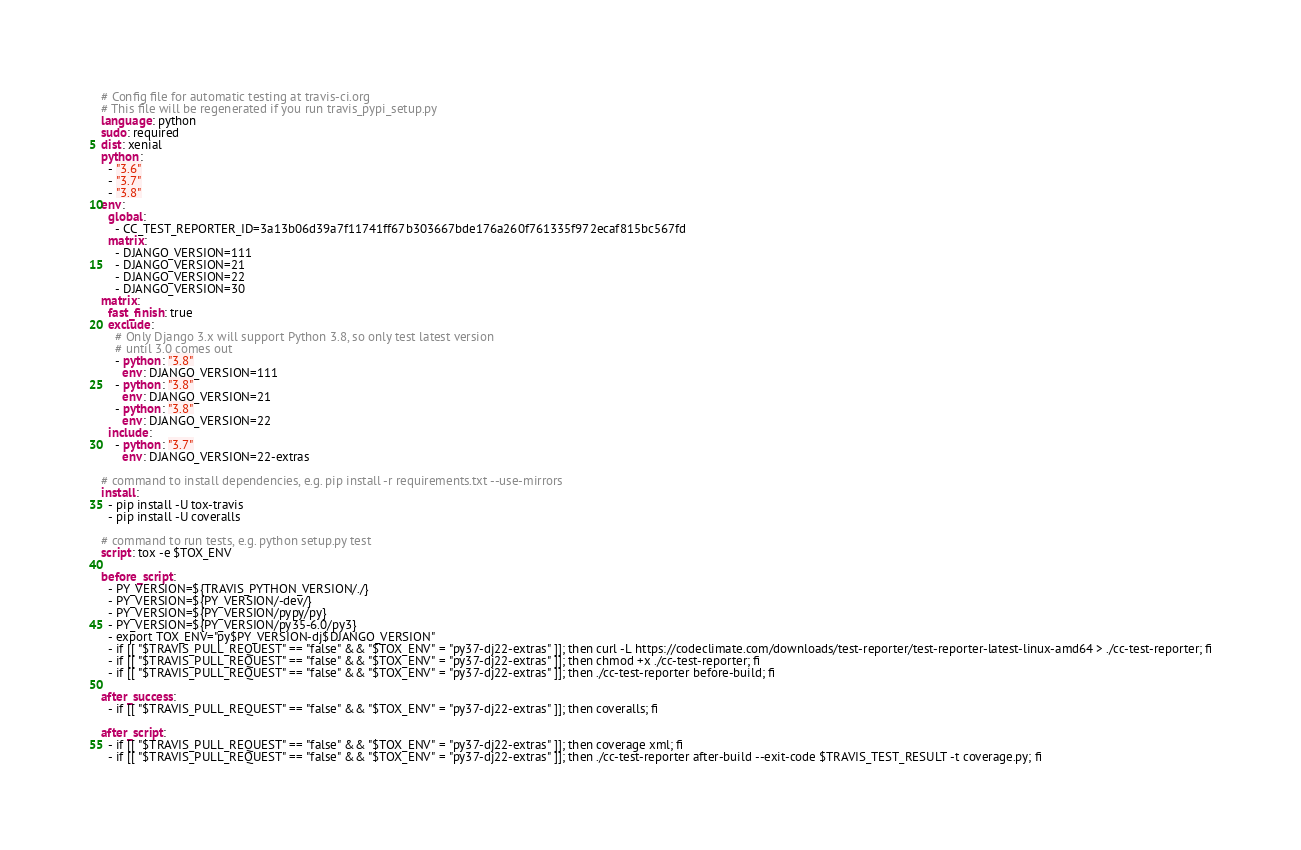<code> <loc_0><loc_0><loc_500><loc_500><_YAML_># Config file for automatic testing at travis-ci.org
# This file will be regenerated if you run travis_pypi_setup.py
language: python
sudo: required
dist: xenial
python:
  - "3.6"
  - "3.7"
  - "3.8"
env:
  global:
    - CC_TEST_REPORTER_ID=3a13b06d39a7f11741ff67b303667bde176a260f761335f972ecaf815bc567fd
  matrix:
    - DJANGO_VERSION=111
    - DJANGO_VERSION=21
    - DJANGO_VERSION=22
    - DJANGO_VERSION=30
matrix:
  fast_finish: true
  exclude:
    # Only Django 3.x will support Python 3.8, so only test latest version
    # until 3.0 comes out
    - python: "3.8"
      env: DJANGO_VERSION=111
    - python: "3.8"
      env: DJANGO_VERSION=21
    - python: "3.8"
      env: DJANGO_VERSION=22
  include:
    - python: "3.7"
      env: DJANGO_VERSION=22-extras

# command to install dependencies, e.g. pip install -r requirements.txt --use-mirrors
install:
  - pip install -U tox-travis
  - pip install -U coveralls

# command to run tests, e.g. python setup.py test
script: tox -e $TOX_ENV

before_script:
  - PY_VERSION=${TRAVIS_PYTHON_VERSION/./}
  - PY_VERSION=${PY_VERSION/-dev/}
  - PY_VERSION=${PY_VERSION/pypy/py}
  - PY_VERSION=${PY_VERSION/py35-6.0/py3}
  - export TOX_ENV="py$PY_VERSION-dj$DJANGO_VERSION"
  - if [[ "$TRAVIS_PULL_REQUEST" == "false" && "$TOX_ENV" = "py37-dj22-extras" ]]; then curl -L https://codeclimate.com/downloads/test-reporter/test-reporter-latest-linux-amd64 > ./cc-test-reporter; fi
  - if [[ "$TRAVIS_PULL_REQUEST" == "false" && "$TOX_ENV" = "py37-dj22-extras" ]]; then chmod +x ./cc-test-reporter; fi
  - if [[ "$TRAVIS_PULL_REQUEST" == "false" && "$TOX_ENV" = "py37-dj22-extras" ]]; then ./cc-test-reporter before-build; fi

after_success:
  - if [[ "$TRAVIS_PULL_REQUEST" == "false" && "$TOX_ENV" = "py37-dj22-extras" ]]; then coveralls; fi

after_script:
  - if [[ "$TRAVIS_PULL_REQUEST" == "false" && "$TOX_ENV" = "py37-dj22-extras" ]]; then coverage xml; fi
  - if [[ "$TRAVIS_PULL_REQUEST" == "false" && "$TOX_ENV" = "py37-dj22-extras" ]]; then ./cc-test-reporter after-build --exit-code $TRAVIS_TEST_RESULT -t coverage.py; fi
</code> 